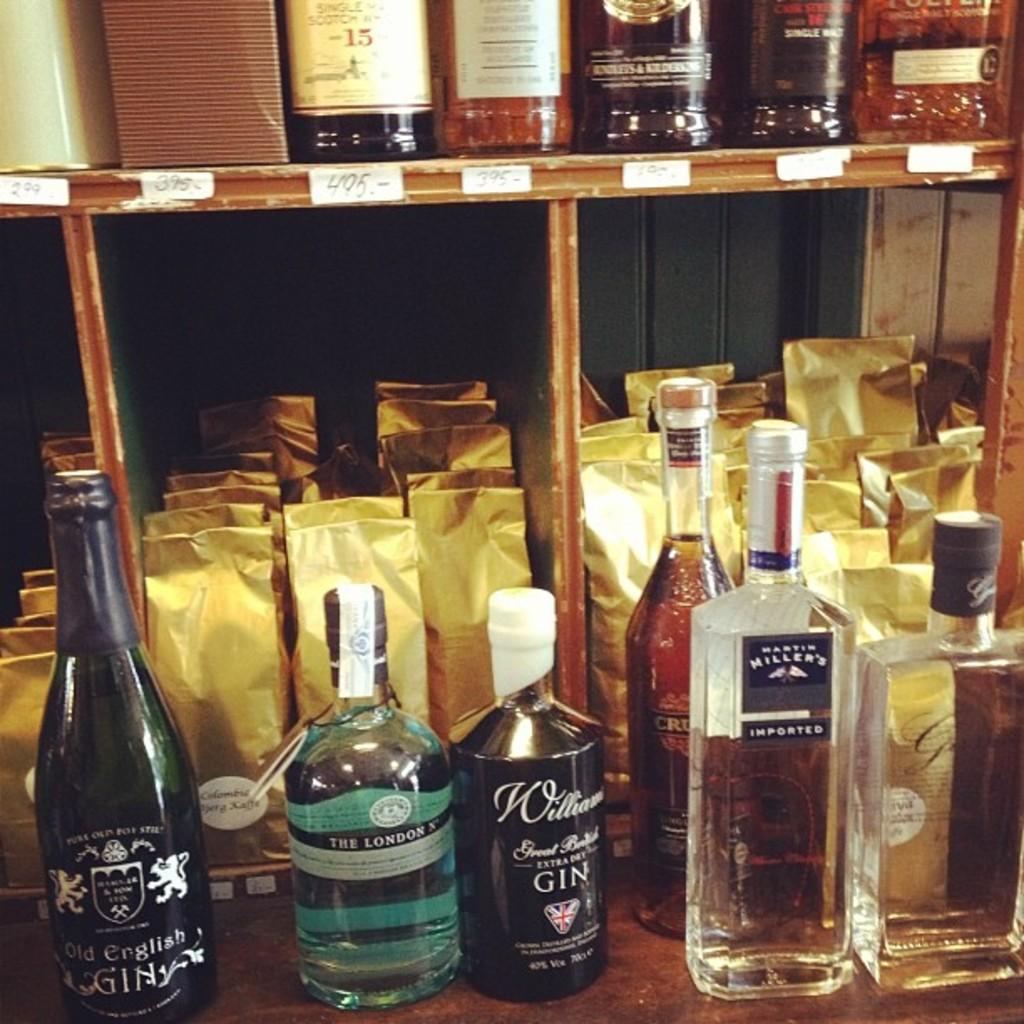What type of liquor is in the short, black bottle?
Offer a very short reply. Gin. 